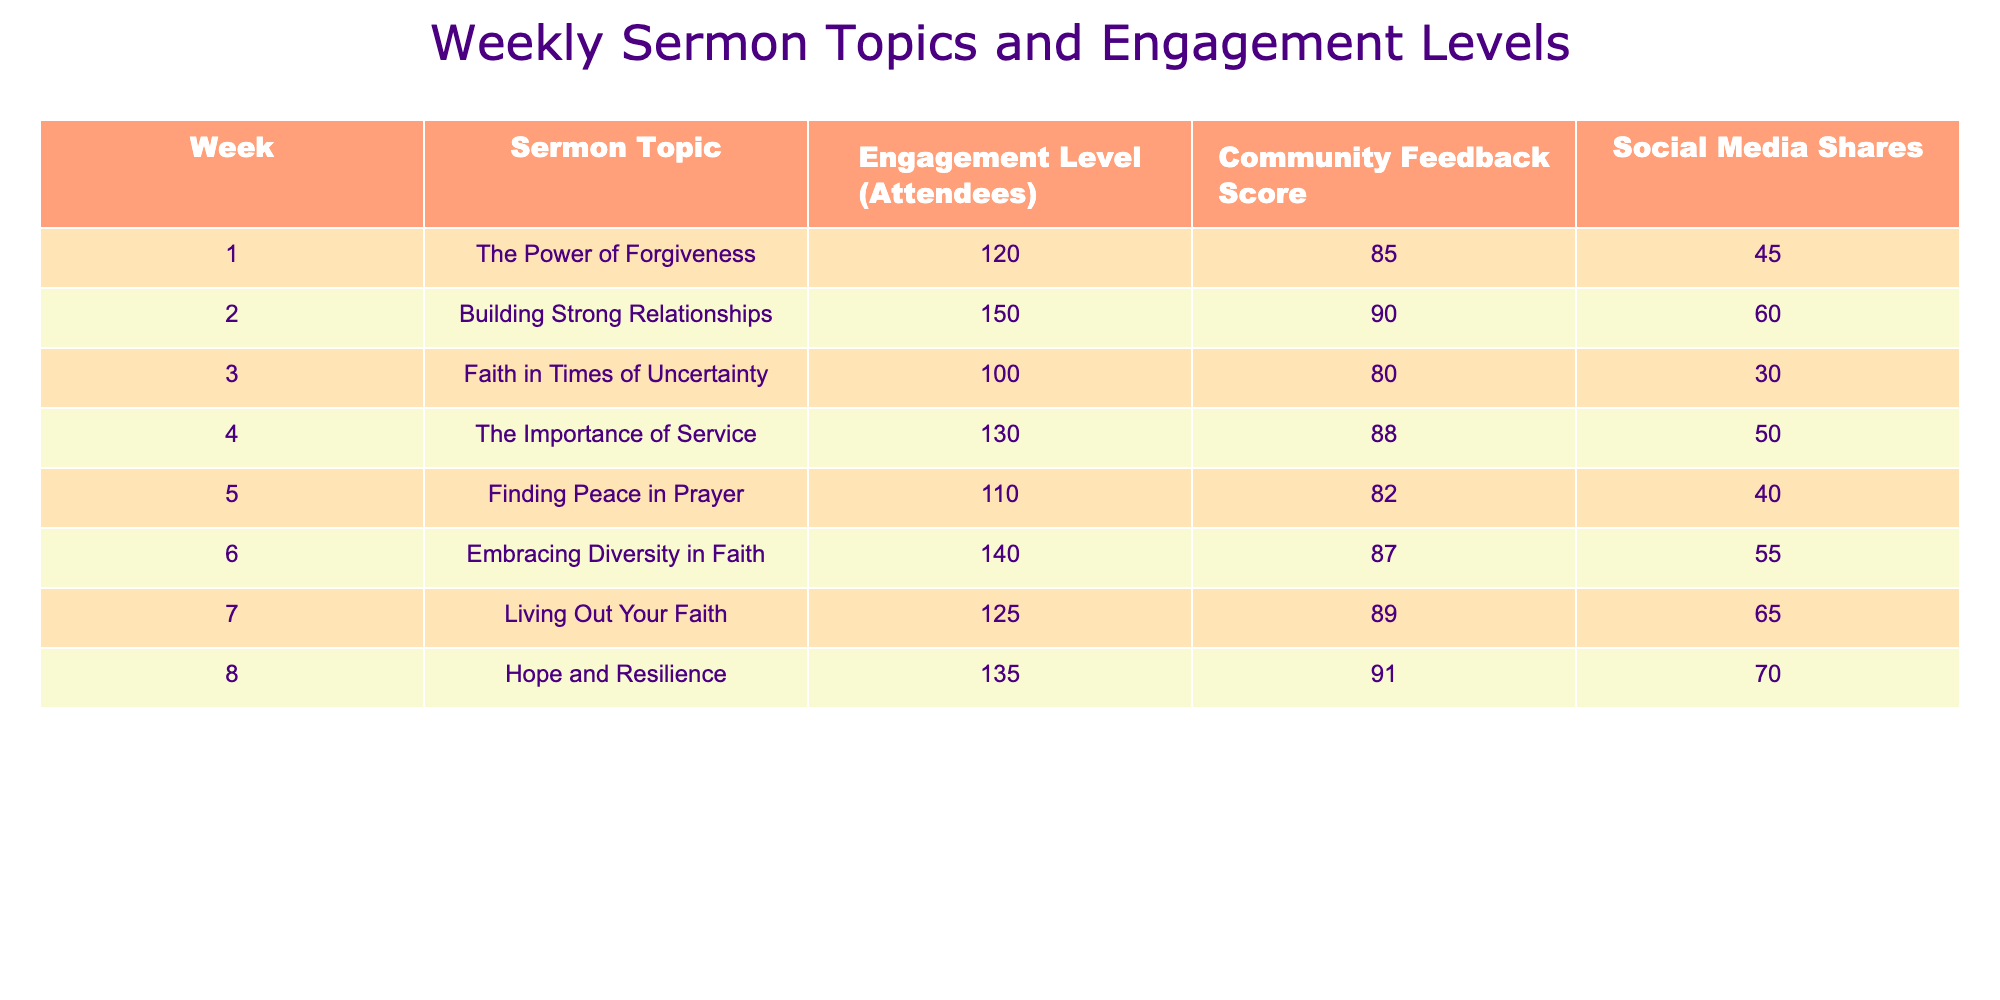What was the highest engagement level across the sermon topics? From the table, the engagement levels are: 120, 150, 100, 130, 110, 140, 125, and 135. The highest value among these is 150, which corresponds to the sermon topic "Building Strong Relationships."
Answer: 150 What is the average Community Feedback Score for the sermons? To calculate the average, we take the sum of the Community Feedback Scores: 85 + 90 + 80 + 88 + 82 + 87 + 89 + 91 = 692. There are 8 scores, so the average is 692 / 8 = 86.5.
Answer: 86.5 Did the sermon on "Faith in Times of Uncertainty" receive a Community Feedback Score above 80? The score for "Faith in Times of Uncertainty" is 80. Since 80 is not above 80, the answer is no.
Answer: No Which sermon topic had the most social media shares? By examining the Social Media Shares column: 45, 60, 30, 50, 40, 55, 65, and 70. The highest value is 70 shares, which corresponds to the sermon topic "Hope and Resilience."
Answer: Hope and Resilience What was the difference in engagement levels between "Embracing Diversity in Faith" and "The Importance of Service"? The engagement level for "Embracing Diversity in Faith" is 140 and for "The Importance of Service" it is 130. The difference is 140 - 130 = 10.
Answer: 10 Was the sermon topic that focused on "Finding Peace in Prayer" rated above average for community feedback? The Community Feedback Score for "Finding Peace in Prayer" is 82. Since the average score calculated earlier is 86.5, 82 is below average.
Answer: No Which week had the lowest engagement level, and what was that level? The engagement levels listed in the table were: 120, 150, 100, 130, 110, 140, 125, and 135. The lowest value is 100, which corresponds to Week 3 with the topic "Faith in Times of Uncertainty."
Answer: Week 3, 100 How many weeks had an engagement level of 130 or higher? The engagement levels are 120, 150, 100, 130, 110, 140, 125, and 135. The levels 150, 130, 140, and 135 are all 130 or higher, giving us 4 weeks.
Answer: 4 